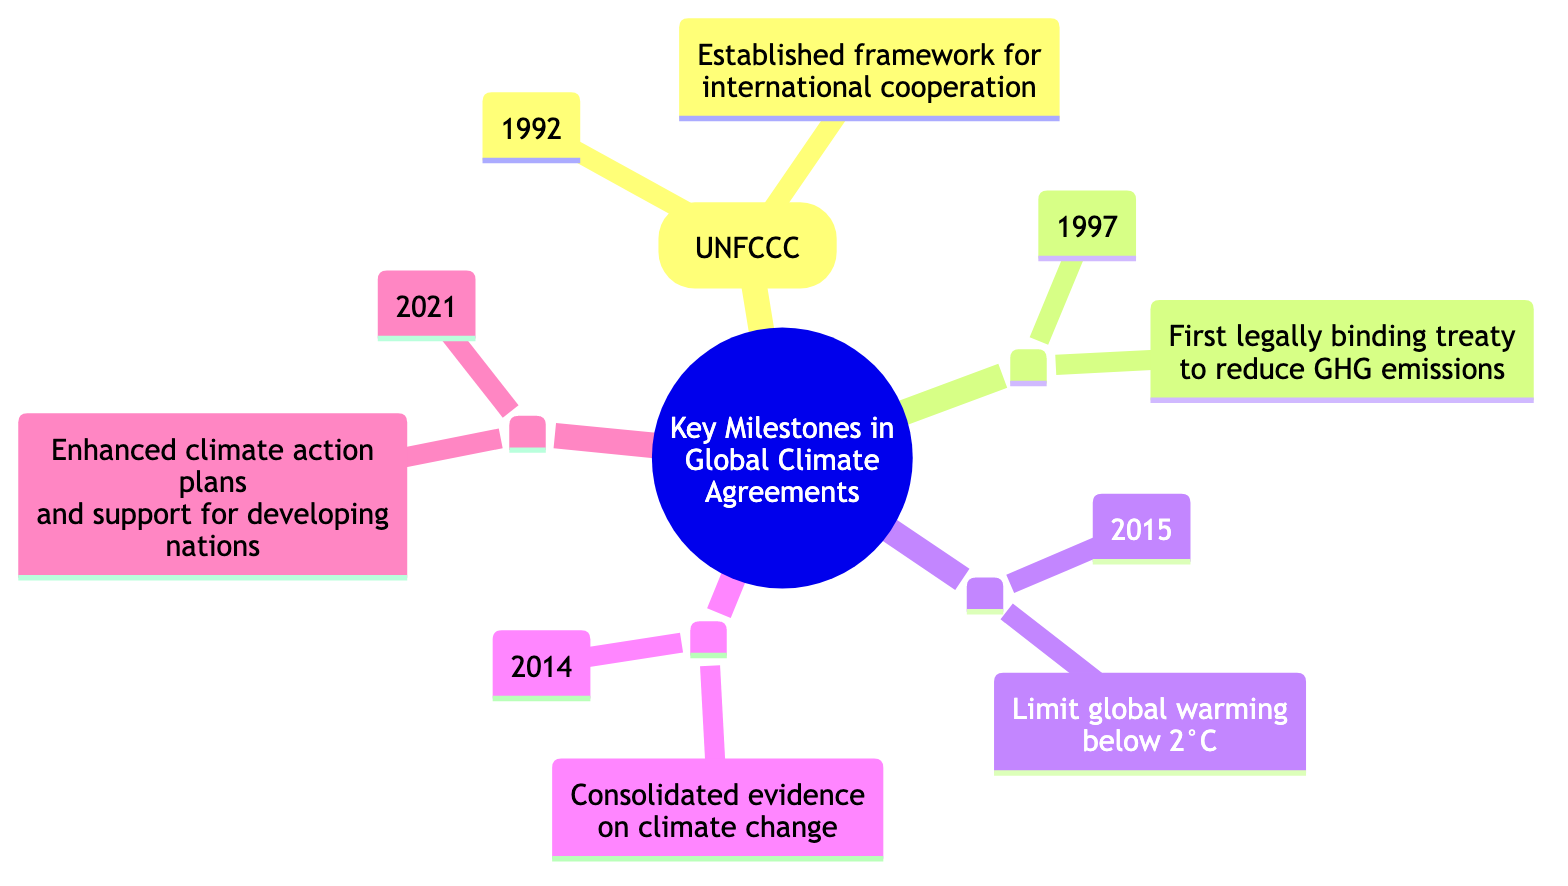What year was the UN Framework Convention on Climate Change established? The diagram indicates that the node for the UN Framework Convention on Climate Change (UNFCCC) lists the year 1992. Thus, the year established is directly referenced.
Answer: 1992 What significant target did the Kyoto Protocol set? The Kyoto Protocol node specifies that it was the first legally binding treaty to reduce greenhouse gas emissions, setting targets specifically for developed countries. This specifies the nature of the agreement's target.
Answer: Greenhouse gas emissions How many key milestones are represented in the diagram? By counting the main nodes listed under the root node, we find there are five key milestones in total: UNFCCC, Kyoto Protocol, Paris Agreement, IPCC Fifth Assessment Report, and Glasgow Climate Pact.
Answer: 5 What is the significance of the Paris Agreement? The Paris Agreement node indicates that its significance is the global commitment to limit global warming to below 2 degrees Celsius compared to pre-industrial levels. This depicts the main objective of the agreement.
Answer: Limit global warming below 2 degrees Celsius Which milestone preceded the Glasgow Climate Pact? By looking at the timeline of the milestones in the diagram, the Glasgow Climate Pact node appears last. The previous milestone listed before it is the Paris Agreement, which was established in 2015.
Answer: Paris Agreement What was the nature of the commitments made in the Glasgow Climate Pact? The description under the Glasgow Climate Pact node states that it set commitments for countries to enhance their climate action plans and support for developing nations, indicating its focus on improvement and support.
Answer: Enhance climate action plans What year did the IPCC Fifth Assessment Report consolidate evidence on climate change? The diagram shows that the IPCC Fifth Assessment Report was published in the year 2014, which is specified under this milestone's information. Therefore, the year of consolidation is directly mentioned.
Answer: 2014 Which agreement established a framework for international cooperation? The diagram indicates that the UN Framework Convention on Climate Change (UNFCCC) is the agreement that established a framework for international cooperation to combat climate change, as noted in its significance.
Answer: UN Framework Convention on Climate Change (UNFCCC) How does the Kyoto Protocol differ from the Paris Agreement? The Kyoto Protocol is characterized as the first legally binding treaty to reduce greenhouse gas emissions with specific targets for developed countries, while the Paris Agreement focuses more broadly on global commitment to limit warming, indicating a shift to more inclusive, long-term goals.
Answer: Legally binding treaty vs. global commitment 